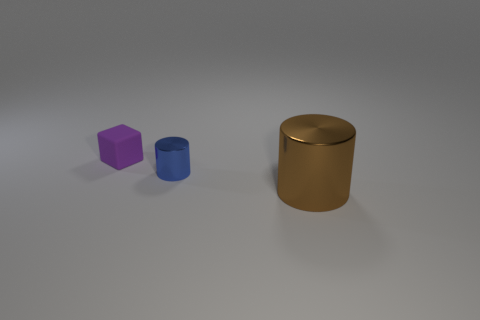Are the objects arranged in any significant pattern? The objects are arranged linearly with equal spacing, conveying a sense of order. There's no apparent symbolic pattern, but the arrangement might suggest a progression in shape from the angular cube to the rounded cylinders. 